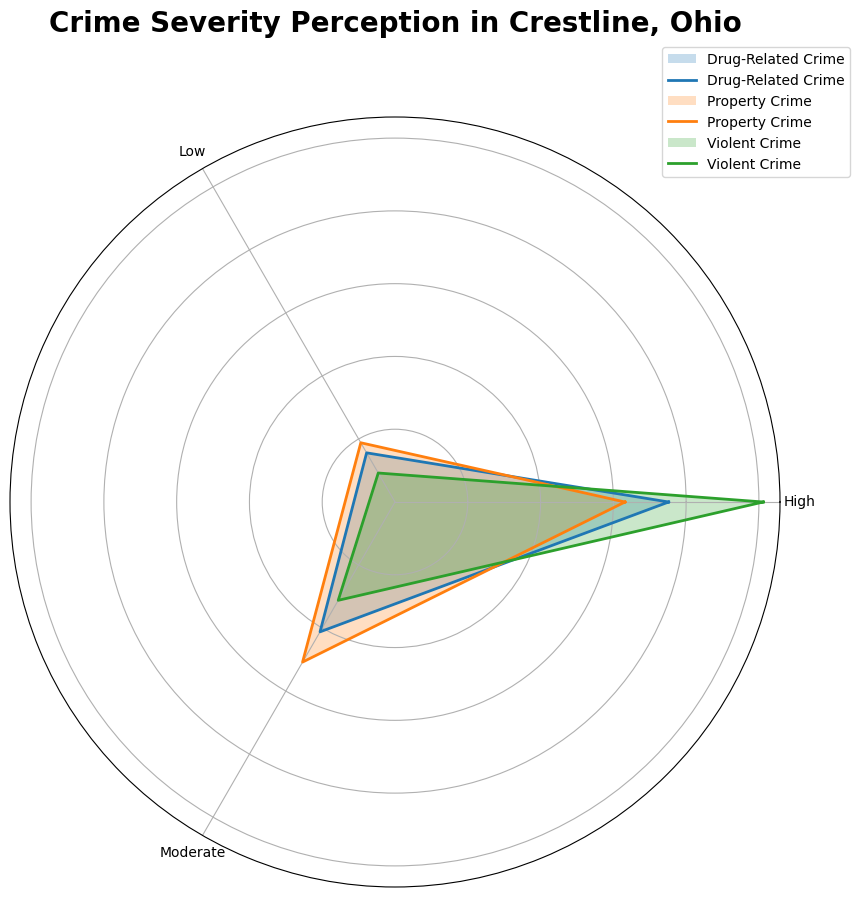Which crime type has the highest perception of severity as "High"? To determine which crime type has the highest perception of severity as "High," we look at the segments corresponding to "High" perception for each crime type and compare their lengths. The segment for Violent Crime is the longest in the "High" category.
Answer: Violent Crime How does the perception of Drug-Related Crime severity compare with Property Crime severity in the "Moderate" category? To compare the "Moderate" perception between Drug-Related Crime and Property Crime, look at the "Moderate" segments for both. The length of the "Moderate" segment for Drug-Related Crime is shorter than for Property Crime.
Answer: Drug-Related Crime is perceived as less severe than Property Crime What is the total number of residents who perceive any type of crime severity as "Low"? Sum the values for the "Low" category across all crime types. Violent Crime: 5 + 10 + 8 = 23, Property Crime: 15 + 20 + 12 = 47, Drug-Related Crime: 10 + 15 + 14 = 39. Therefore, 23 + 47 + 39 = 109 residents perceived crime severity as "Low."
Answer: 109 Which crime type has the most evenly distributed perception across High, Moderate, and Low categories? To find which crime type has the most evenly distributed perception, examine the width of the segments for each crime type across all categories. Property Crime segments (High, Moderate, Low) appear to be the most balanced across the three perception levels.
Answer: Property Crime What percentage of residents perceive Violent Crime severity as either "Moderate" or "Low"? For Violent Crime, sum the "Moderate" and "Low" values: 20 + 5 = 25, 30 + 10 = 40, 28 + 8 = 36. Total residents surveyed: 80 + 85 + 88 = 253. Percentage calculation: (25 + 40 + 36) / 253 * 100 = 101 / 253 * 100 ≈ 39.9%.
Answer: 39.9% How does the perception of severity for Violent Crime as "Moderate" compare to Property Crime in the same category? To compare the perception of severity of Violent Crime and Property Crime as "Moderate," observe the "Moderate" segments for each. The "Moderate" perception segment for Violent Crime is shorter than that for Property Crime.
Answer: Violent Crime is perceived as less severe than Property Crime Is the perception of drug-related crime severity skewed more towards "High" or "Low"? To determine this, compare the "High" and "Low" segments for Drug-Related Crime. The "High" segment is longer than the "Low" segment, indicating a skew towards "High" perception.
Answer: High 